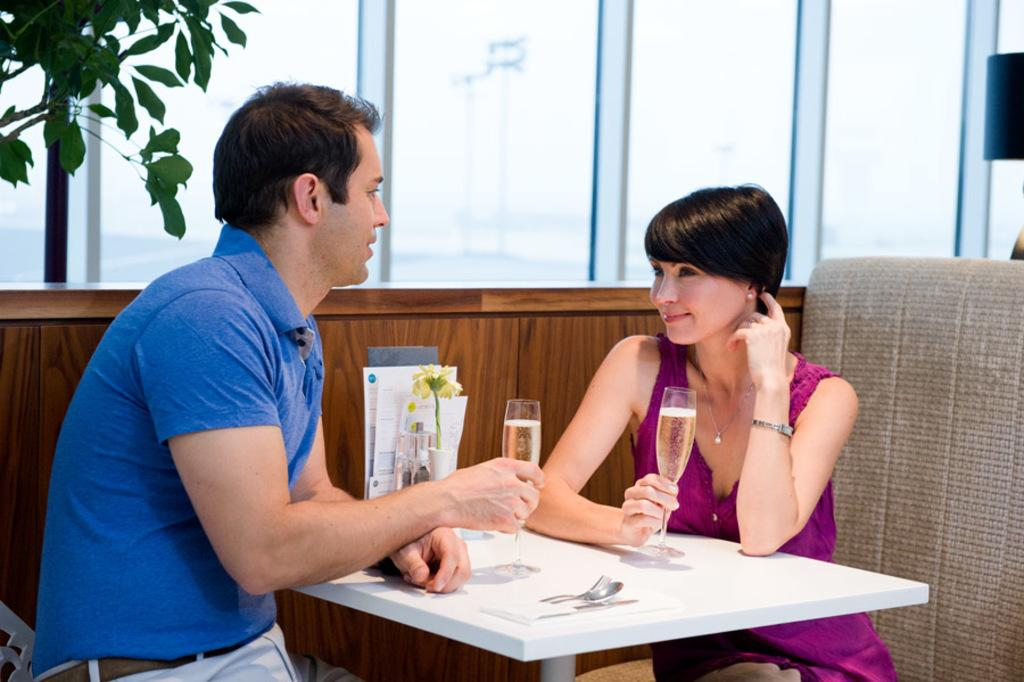Who is present in the image? There is a couple in the image. What are they doing in the image? The couple is sitting on a sofa and having a drink. What is their emotional state in the image? The couple is smiling in the image. What can be seen through the glass window in the image? The facts do not specify what can be seen through the glass window. What is on the left side of the image? There is a tree on the left side of the image. What type of robin is perched on the partner's shoulder in the image? There is no robin present in the image. What type of cast is on the couple's arm in the image? There is no cast visible on the couple's arm in the image. 